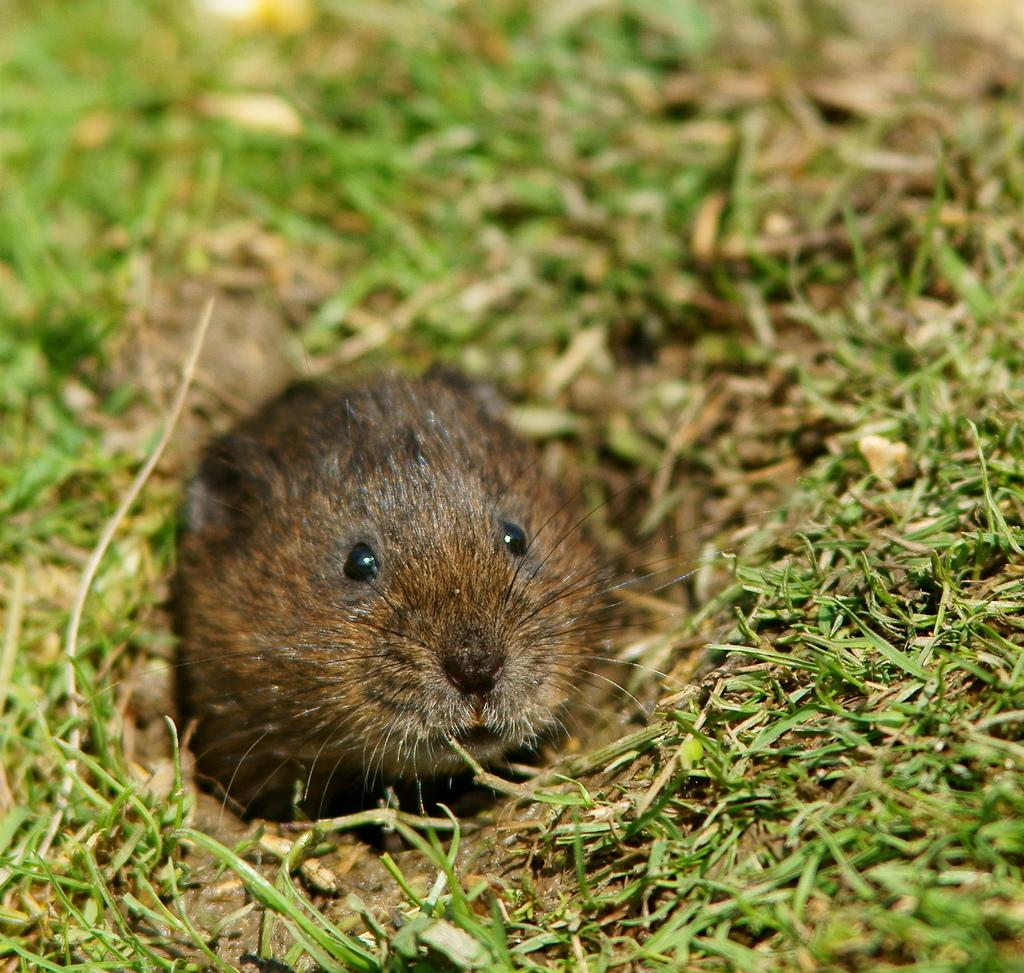What animal can be seen in the hole in the image? There is a rat in the hole in the image. What type of vegetation is visible in the image? There is grass visible in the image. Can you describe the quality of the image at the top? The top of the image is blurred. What type of clover is the boy holding in the image? There is no boy or clover present in the image; it features a rat in a hole and grass. 